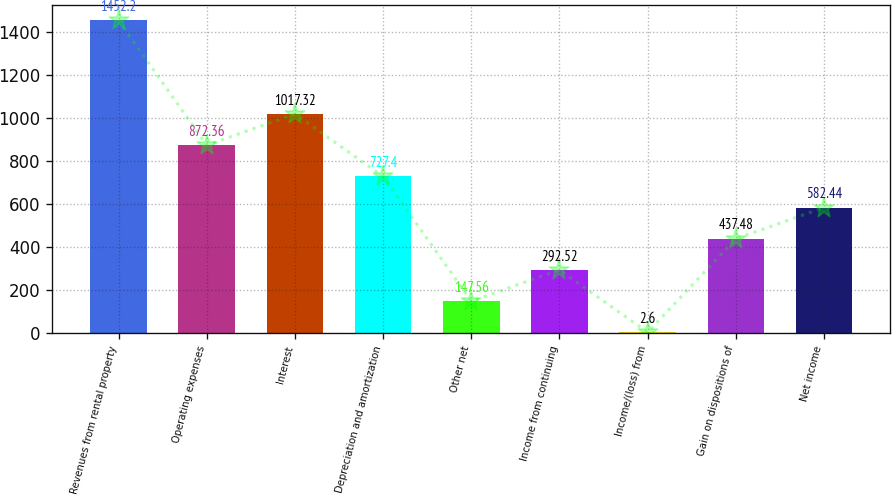Convert chart to OTSL. <chart><loc_0><loc_0><loc_500><loc_500><bar_chart><fcel>Revenues from rental property<fcel>Operating expenses<fcel>Interest<fcel>Depreciation and amortization<fcel>Other net<fcel>Income from continuing<fcel>Income/(loss) from<fcel>Gain on dispositions of<fcel>Net income<nl><fcel>1452.2<fcel>872.36<fcel>1017.32<fcel>727.4<fcel>147.56<fcel>292.52<fcel>2.6<fcel>437.48<fcel>582.44<nl></chart> 